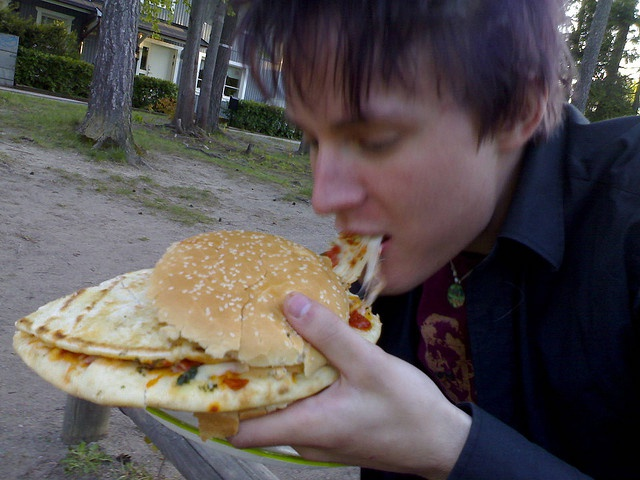Describe the objects in this image and their specific colors. I can see people in gray, black, darkgray, and maroon tones and sandwich in gray, tan, darkgray, and lightgray tones in this image. 